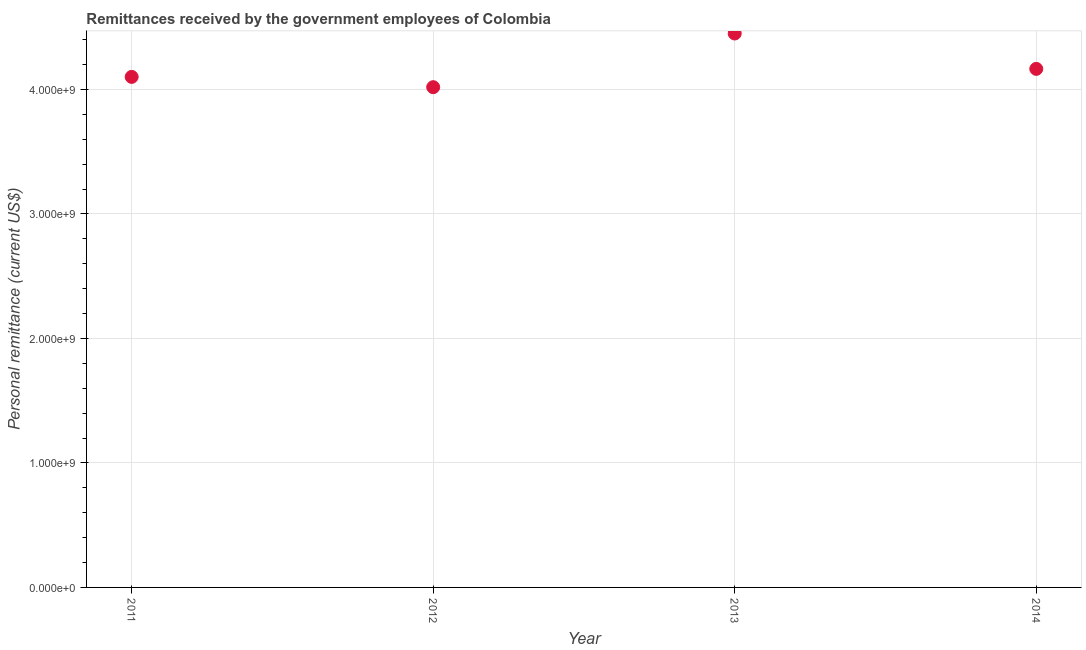What is the personal remittances in 2014?
Your response must be concise. 4.17e+09. Across all years, what is the maximum personal remittances?
Provide a succinct answer. 4.45e+09. Across all years, what is the minimum personal remittances?
Keep it short and to the point. 4.02e+09. In which year was the personal remittances maximum?
Offer a very short reply. 2013. In which year was the personal remittances minimum?
Provide a short and direct response. 2012. What is the sum of the personal remittances?
Your answer should be very brief. 1.67e+1. What is the difference between the personal remittances in 2011 and 2013?
Ensure brevity in your answer.  -3.49e+08. What is the average personal remittances per year?
Keep it short and to the point. 4.18e+09. What is the median personal remittances?
Give a very brief answer. 4.13e+09. In how many years, is the personal remittances greater than 2400000000 US$?
Ensure brevity in your answer.  4. Do a majority of the years between 2013 and 2012 (inclusive) have personal remittances greater than 600000000 US$?
Your answer should be very brief. No. What is the ratio of the personal remittances in 2011 to that in 2013?
Your answer should be compact. 0.92. Is the difference between the personal remittances in 2011 and 2014 greater than the difference between any two years?
Offer a very short reply. No. What is the difference between the highest and the second highest personal remittances?
Your response must be concise. 2.84e+08. Is the sum of the personal remittances in 2011 and 2012 greater than the maximum personal remittances across all years?
Keep it short and to the point. Yes. What is the difference between the highest and the lowest personal remittances?
Your answer should be very brief. 4.31e+08. Are the values on the major ticks of Y-axis written in scientific E-notation?
Provide a succinct answer. Yes. Does the graph contain any zero values?
Your response must be concise. No. Does the graph contain grids?
Provide a short and direct response. Yes. What is the title of the graph?
Your response must be concise. Remittances received by the government employees of Colombia. What is the label or title of the Y-axis?
Provide a succinct answer. Personal remittance (current US$). What is the Personal remittance (current US$) in 2011?
Make the answer very short. 4.10e+09. What is the Personal remittance (current US$) in 2012?
Your answer should be very brief. 4.02e+09. What is the Personal remittance (current US$) in 2013?
Your answer should be compact. 4.45e+09. What is the Personal remittance (current US$) in 2014?
Your answer should be compact. 4.17e+09. What is the difference between the Personal remittance (current US$) in 2011 and 2012?
Offer a very short reply. 8.26e+07. What is the difference between the Personal remittance (current US$) in 2011 and 2013?
Your response must be concise. -3.49e+08. What is the difference between the Personal remittance (current US$) in 2011 and 2014?
Provide a short and direct response. -6.44e+07. What is the difference between the Personal remittance (current US$) in 2012 and 2013?
Keep it short and to the point. -4.31e+08. What is the difference between the Personal remittance (current US$) in 2012 and 2014?
Provide a short and direct response. -1.47e+08. What is the difference between the Personal remittance (current US$) in 2013 and 2014?
Ensure brevity in your answer.  2.84e+08. What is the ratio of the Personal remittance (current US$) in 2011 to that in 2013?
Your answer should be compact. 0.92. What is the ratio of the Personal remittance (current US$) in 2012 to that in 2013?
Give a very brief answer. 0.9. What is the ratio of the Personal remittance (current US$) in 2012 to that in 2014?
Your answer should be very brief. 0.96. What is the ratio of the Personal remittance (current US$) in 2013 to that in 2014?
Provide a succinct answer. 1.07. 